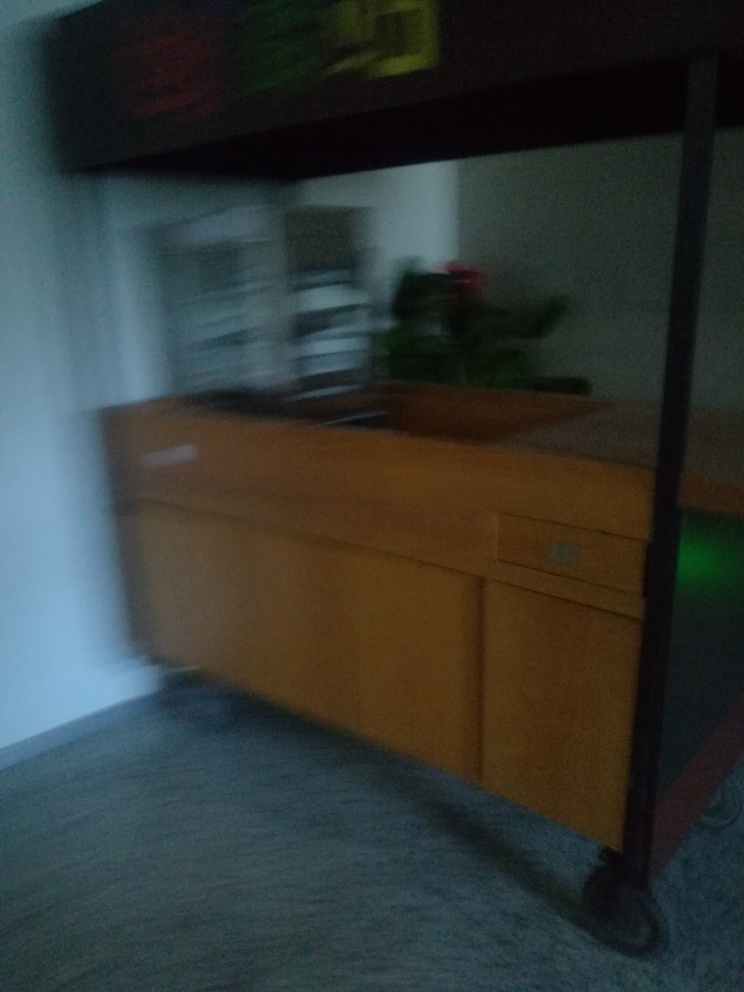What is the result of the motion blur?
A. Blur
B. Sharpness
C. Detail The result of the motion blur in the image is a loss of sharpness, resulting in an overall blur. Moving objects or a shaking camera during the capture can cause such an effect, where the details are smeared along the direction of the motion, leaving a trail of blurred lines across the image. 